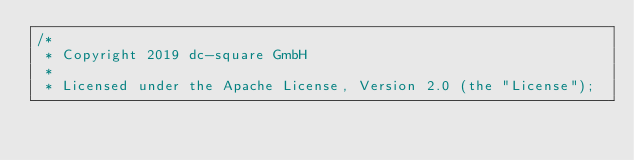Convert code to text. <code><loc_0><loc_0><loc_500><loc_500><_Java_>/*
 * Copyright 2019 dc-square GmbH
 *
 * Licensed under the Apache License, Version 2.0 (the "License");</code> 